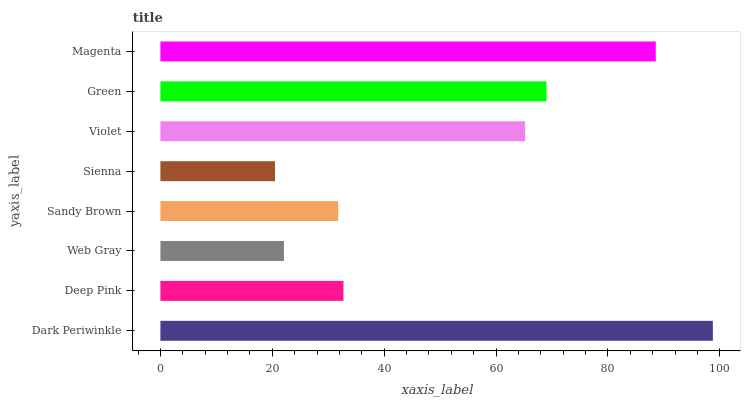Is Sienna the minimum?
Answer yes or no. Yes. Is Dark Periwinkle the maximum?
Answer yes or no. Yes. Is Deep Pink the minimum?
Answer yes or no. No. Is Deep Pink the maximum?
Answer yes or no. No. Is Dark Periwinkle greater than Deep Pink?
Answer yes or no. Yes. Is Deep Pink less than Dark Periwinkle?
Answer yes or no. Yes. Is Deep Pink greater than Dark Periwinkle?
Answer yes or no. No. Is Dark Periwinkle less than Deep Pink?
Answer yes or no. No. Is Violet the high median?
Answer yes or no. Yes. Is Deep Pink the low median?
Answer yes or no. Yes. Is Web Gray the high median?
Answer yes or no. No. Is Green the low median?
Answer yes or no. No. 